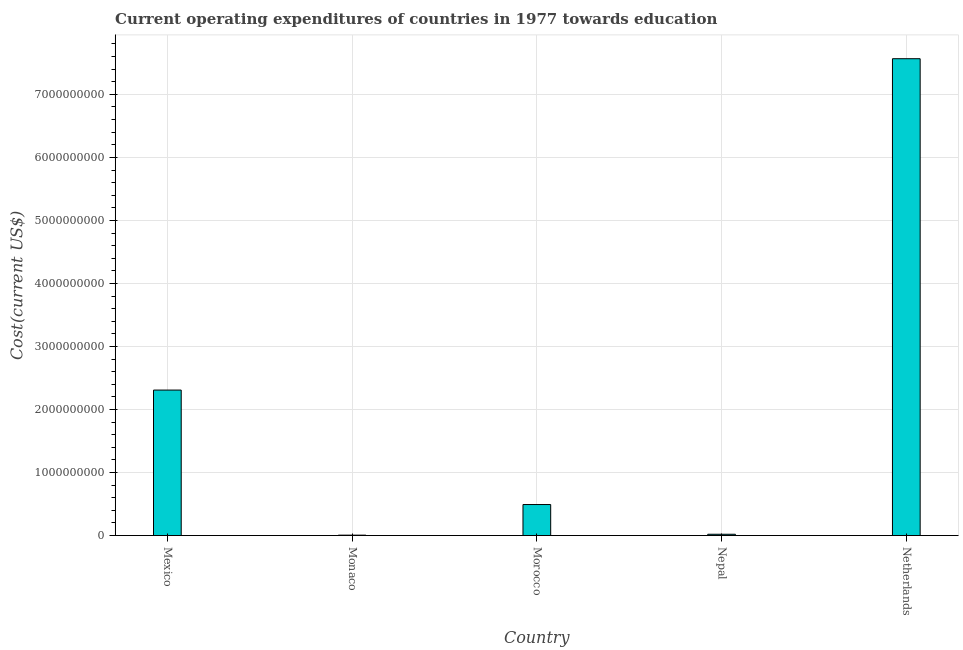Does the graph contain grids?
Offer a terse response. Yes. What is the title of the graph?
Give a very brief answer. Current operating expenditures of countries in 1977 towards education. What is the label or title of the X-axis?
Provide a succinct answer. Country. What is the label or title of the Y-axis?
Your answer should be compact. Cost(current US$). What is the education expenditure in Monaco?
Provide a short and direct response. 6.49e+06. Across all countries, what is the maximum education expenditure?
Offer a very short reply. 7.57e+09. Across all countries, what is the minimum education expenditure?
Give a very brief answer. 6.49e+06. In which country was the education expenditure maximum?
Offer a terse response. Netherlands. In which country was the education expenditure minimum?
Your response must be concise. Monaco. What is the sum of the education expenditure?
Give a very brief answer. 1.04e+1. What is the difference between the education expenditure in Monaco and Morocco?
Your answer should be very brief. -4.86e+08. What is the average education expenditure per country?
Provide a succinct answer. 2.08e+09. What is the median education expenditure?
Provide a succinct answer. 4.92e+08. In how many countries, is the education expenditure greater than 5600000000 US$?
Keep it short and to the point. 1. What is the ratio of the education expenditure in Mexico to that in Monaco?
Keep it short and to the point. 355.67. Is the education expenditure in Morocco less than that in Nepal?
Ensure brevity in your answer.  No. Is the difference between the education expenditure in Monaco and Morocco greater than the difference between any two countries?
Make the answer very short. No. What is the difference between the highest and the second highest education expenditure?
Offer a very short reply. 5.26e+09. What is the difference between the highest and the lowest education expenditure?
Provide a succinct answer. 7.56e+09. In how many countries, is the education expenditure greater than the average education expenditure taken over all countries?
Ensure brevity in your answer.  2. How many bars are there?
Your answer should be very brief. 5. Are all the bars in the graph horizontal?
Offer a very short reply. No. What is the difference between two consecutive major ticks on the Y-axis?
Provide a short and direct response. 1.00e+09. What is the Cost(current US$) of Mexico?
Your answer should be compact. 2.31e+09. What is the Cost(current US$) in Monaco?
Make the answer very short. 6.49e+06. What is the Cost(current US$) of Morocco?
Make the answer very short. 4.92e+08. What is the Cost(current US$) in Nepal?
Keep it short and to the point. 2.08e+07. What is the Cost(current US$) of Netherlands?
Offer a very short reply. 7.57e+09. What is the difference between the Cost(current US$) in Mexico and Monaco?
Provide a succinct answer. 2.30e+09. What is the difference between the Cost(current US$) in Mexico and Morocco?
Offer a very short reply. 1.82e+09. What is the difference between the Cost(current US$) in Mexico and Nepal?
Provide a succinct answer. 2.29e+09. What is the difference between the Cost(current US$) in Mexico and Netherlands?
Keep it short and to the point. -5.26e+09. What is the difference between the Cost(current US$) in Monaco and Morocco?
Give a very brief answer. -4.86e+08. What is the difference between the Cost(current US$) in Monaco and Nepal?
Make the answer very short. -1.43e+07. What is the difference between the Cost(current US$) in Monaco and Netherlands?
Offer a terse response. -7.56e+09. What is the difference between the Cost(current US$) in Morocco and Nepal?
Give a very brief answer. 4.71e+08. What is the difference between the Cost(current US$) in Morocco and Netherlands?
Your answer should be compact. -7.07e+09. What is the difference between the Cost(current US$) in Nepal and Netherlands?
Provide a short and direct response. -7.54e+09. What is the ratio of the Cost(current US$) in Mexico to that in Monaco?
Offer a very short reply. 355.67. What is the ratio of the Cost(current US$) in Mexico to that in Morocco?
Provide a short and direct response. 4.69. What is the ratio of the Cost(current US$) in Mexico to that in Nepal?
Ensure brevity in your answer.  110.85. What is the ratio of the Cost(current US$) in Mexico to that in Netherlands?
Your answer should be very brief. 0.3. What is the ratio of the Cost(current US$) in Monaco to that in Morocco?
Provide a short and direct response. 0.01. What is the ratio of the Cost(current US$) in Monaco to that in Nepal?
Provide a short and direct response. 0.31. What is the ratio of the Cost(current US$) in Morocco to that in Nepal?
Your answer should be very brief. 23.63. What is the ratio of the Cost(current US$) in Morocco to that in Netherlands?
Give a very brief answer. 0.07. What is the ratio of the Cost(current US$) in Nepal to that in Netherlands?
Offer a terse response. 0. 